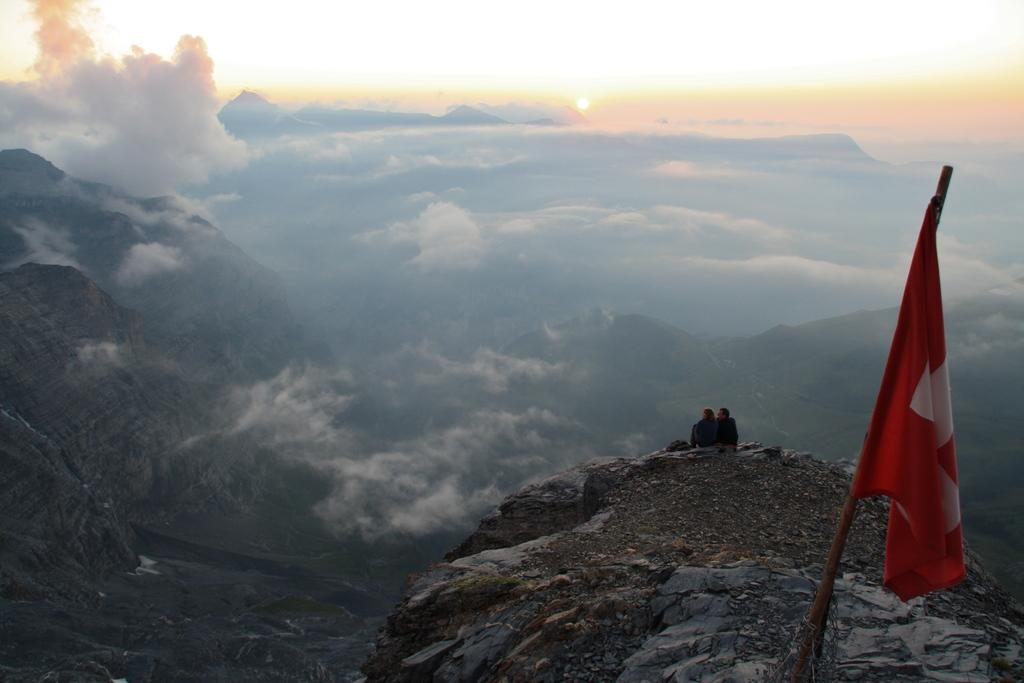What is located on the right side of the image? There is a flag on the right side of the image. What can be seen in the background of the image? There are clouds and hills in the background of the image. What are the people in the image doing? The people are seated in the image. What type of jewel is being used to open the can in the image? There is no can or jewel present in the image. What team is visible in the image? There is no team visible in the image. 